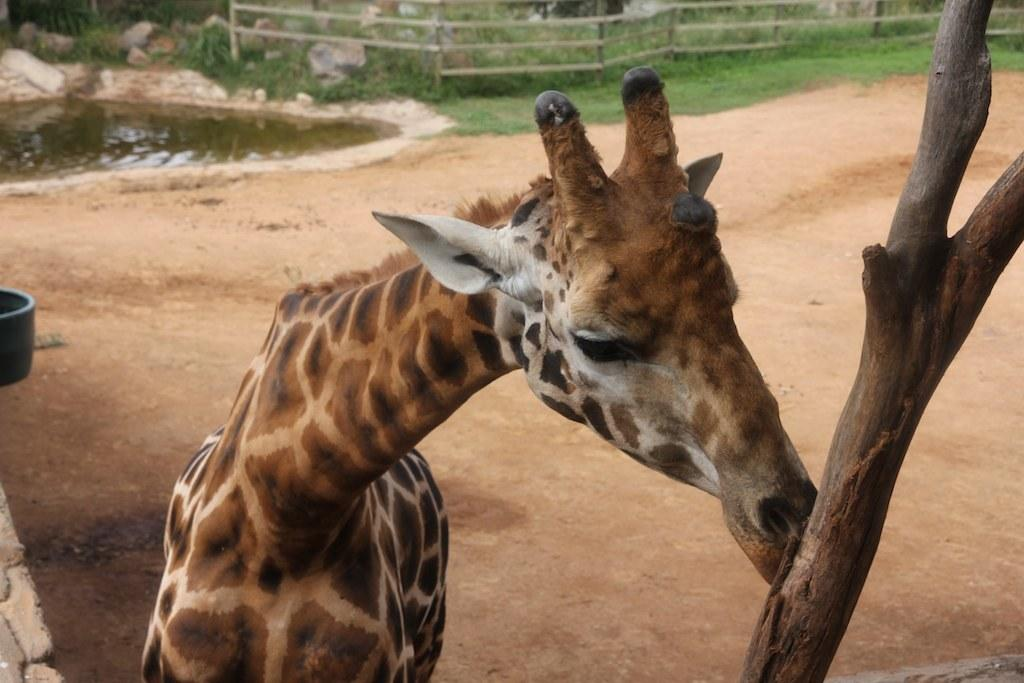What type of animal can be seen in the image? There is a giraffe in the image. What natural element is present in the image? There is a branch of a tree in the image. What object is on the ground in the image? There is a tub on the ground in the image. What body of water is visible in the image? There is a pond in the image. What type of vegetation is present in the image? There is grass in the image. What type of material is used for the stones in the image? The stones in the image are made of a hard, solid material. What type of barrier is present in the image? There is a wooden fence in the image. What type of pest can be seen crawling on the wooden fence in the image? There are no pests visible on the wooden fence in the image. 